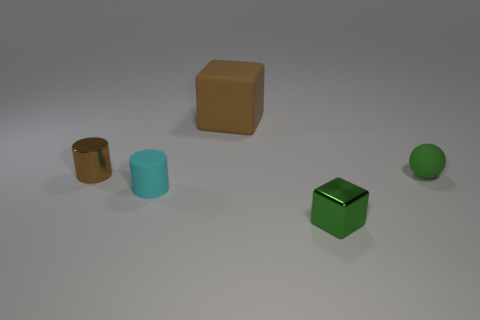Are there the same number of small cubes that are on the left side of the big brown matte thing and small cyan rubber things?
Your answer should be compact. No. How many other things are there of the same material as the brown cylinder?
Ensure brevity in your answer.  1. Do the brown object that is left of the large brown object and the block in front of the tiny green rubber thing have the same size?
Offer a terse response. Yes. How many things are small shiny things that are on the left side of the green metal object or blocks that are behind the brown metal thing?
Keep it short and to the point. 2. Is there anything else that is the same shape as the tiny green matte thing?
Ensure brevity in your answer.  No. Does the tiny metal thing left of the big brown object have the same color as the block behind the green rubber thing?
Your answer should be compact. Yes. What number of matte things are either tiny purple objects or cylinders?
Your answer should be very brief. 1. Is there any other thing that is the same size as the rubber block?
Make the answer very short. No. What is the shape of the small rubber object in front of the green thing right of the small block?
Your response must be concise. Cylinder. Do the green thing right of the tiny green cube and the brown thing that is on the left side of the brown rubber block have the same material?
Offer a terse response. No. 